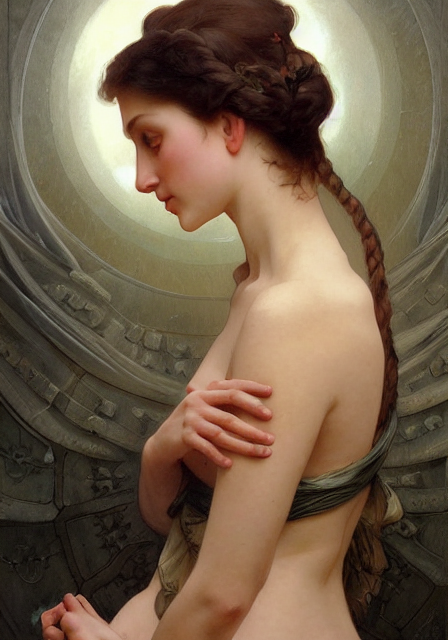What might the halo-like element behind the subject represent? The halo effect often symbolizes sanctity or divinity, suggesting the subject may be depicted as an elevated figure, such as a saint or muse. It also could be interpreted as an aura of enlightenment or a representation of spiritual awakening. 